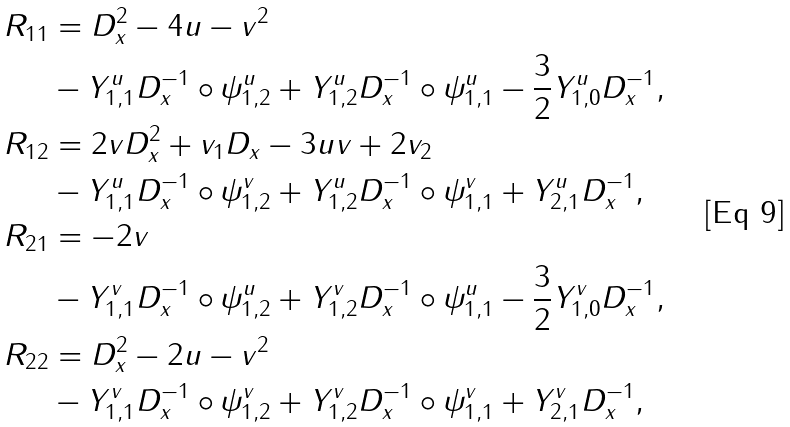Convert formula to latex. <formula><loc_0><loc_0><loc_500><loc_500>R _ { 1 1 } & = D _ { x } ^ { 2 } - 4 u - v ^ { 2 } \\ & - Y _ { 1 , 1 } ^ { u } D _ { x } ^ { - 1 } \circ \psi _ { 1 , 2 } ^ { u } + Y _ { 1 , 2 } ^ { u } D _ { x } ^ { - 1 } \circ \psi _ { 1 , 1 } ^ { u } - \frac { 3 } { 2 } Y _ { 1 , 0 } ^ { u } D _ { x } ^ { - 1 } , \\ R _ { 1 2 } & = 2 v D _ { x } ^ { 2 } + v _ { 1 } D _ { x } - 3 u v + 2 v _ { 2 } \\ & - Y _ { 1 , 1 } ^ { u } D _ { x } ^ { - 1 } \circ \psi _ { 1 , 2 } ^ { v } + Y _ { 1 , 2 } ^ { u } D _ { x } ^ { - 1 } \circ \psi _ { 1 , 1 } ^ { v } + Y _ { 2 , 1 } ^ { u } D _ { x } ^ { - 1 } , \\ R _ { 2 1 } & = - 2 v \\ & - Y _ { 1 , 1 } ^ { v } D _ { x } ^ { - 1 } \circ \psi _ { 1 , 2 } ^ { u } + Y _ { 1 , 2 } ^ { v } D _ { x } ^ { - 1 } \circ \psi _ { 1 , 1 } ^ { u } - \frac { 3 } { 2 } Y _ { 1 , 0 } ^ { v } D _ { x } ^ { - 1 } , \\ R _ { 2 2 } & = D _ { x } ^ { 2 } - 2 u - v ^ { 2 } \\ & - Y _ { 1 , 1 } ^ { v } D _ { x } ^ { - 1 } \circ \psi _ { 1 , 2 } ^ { v } + Y _ { 1 , 2 } ^ { v } D _ { x } ^ { - 1 } \circ \psi _ { 1 , 1 } ^ { v } + Y _ { 2 , 1 } ^ { v } D _ { x } ^ { - 1 } , \\</formula> 